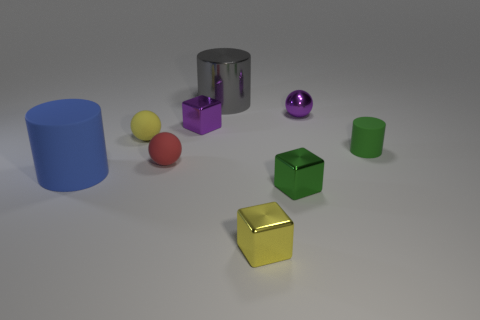Add 1 yellow blocks. How many objects exist? 10 Subtract all cubes. How many objects are left? 6 Subtract all large objects. Subtract all yellow objects. How many objects are left? 5 Add 8 small cylinders. How many small cylinders are left? 9 Add 8 purple things. How many purple things exist? 10 Subtract 1 green cylinders. How many objects are left? 8 